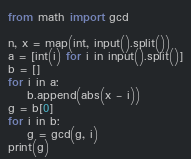<code> <loc_0><loc_0><loc_500><loc_500><_Python_>from math import gcd

n, x = map(int, input().split())
a = [int(i) for i in input().split()]
b = []
for i in a:
    b.append(abs(x - i))
g = b[0]
for i in b:
    g = gcd(g, i)
print(g)</code> 